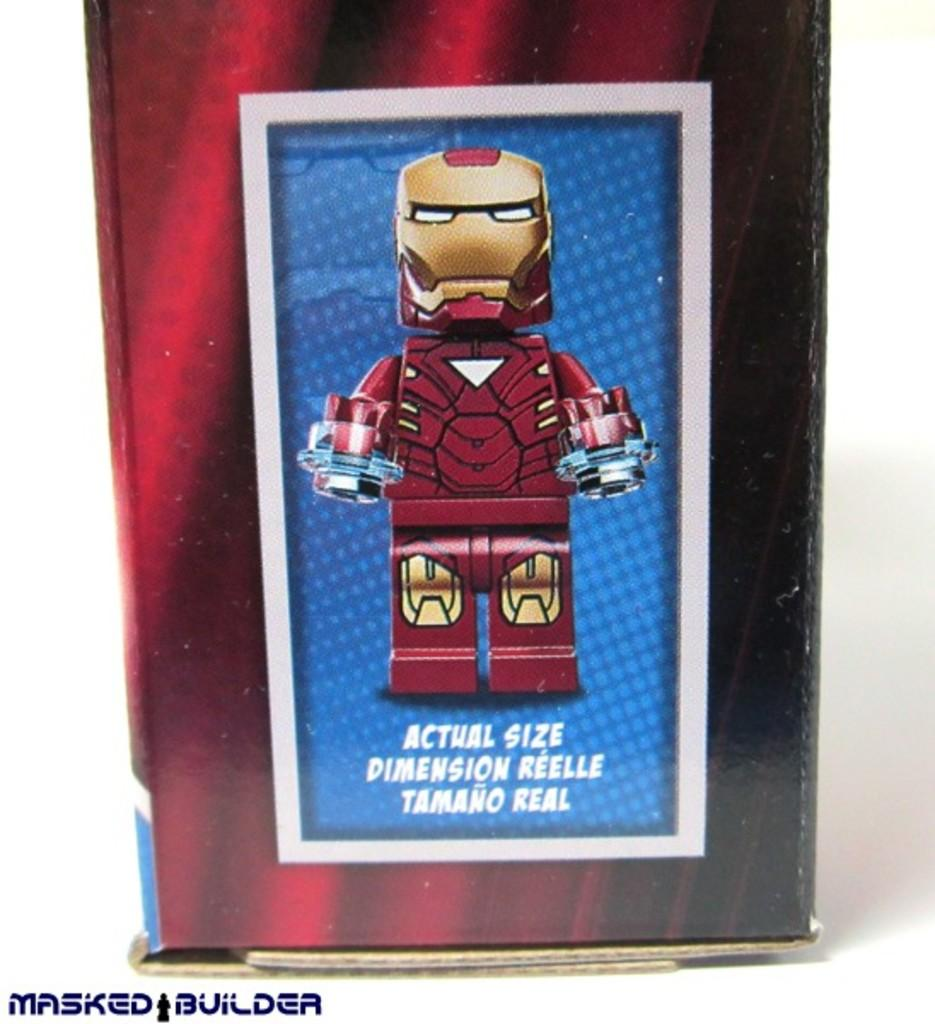What is the main image on the poster? The poster contains an image of a robot. Are there any words on the poster? Yes, there is text on the poster. Is there any additional marking on the poster? Yes, there is a watermark in the left bottom corner of the poster. Can you describe the woman holding a ball and a pencil in the image? There is no woman holding a ball and a pencil in the image; the image features a robot. 